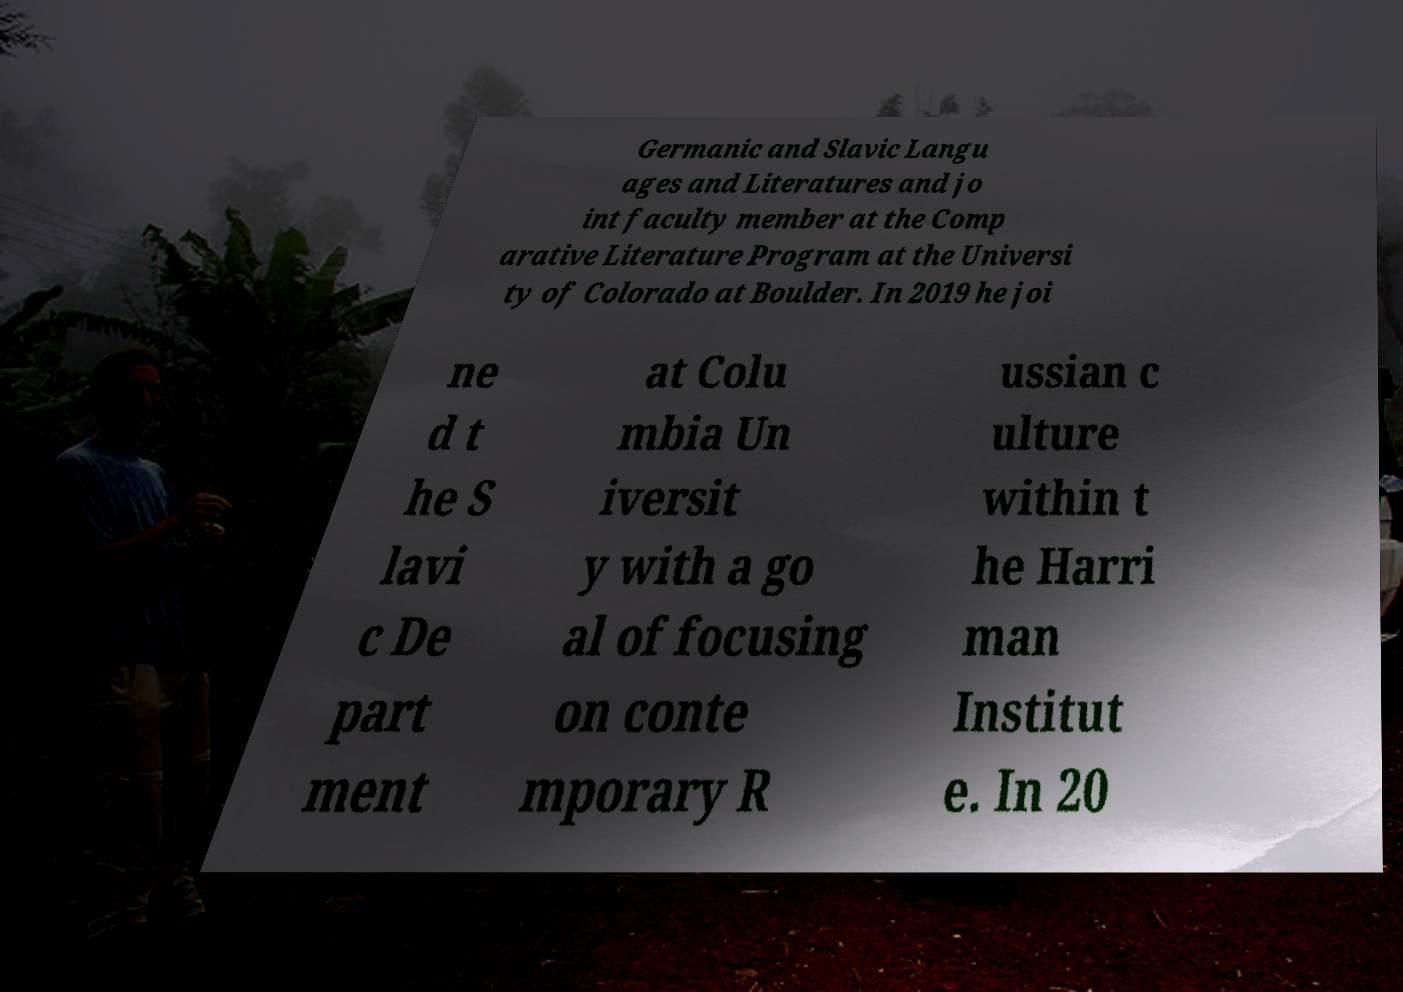Can you accurately transcribe the text from the provided image for me? Germanic and Slavic Langu ages and Literatures and jo int faculty member at the Comp arative Literature Program at the Universi ty of Colorado at Boulder. In 2019 he joi ne d t he S lavi c De part ment at Colu mbia Un iversit y with a go al of focusing on conte mporary R ussian c ulture within t he Harri man Institut e. In 20 